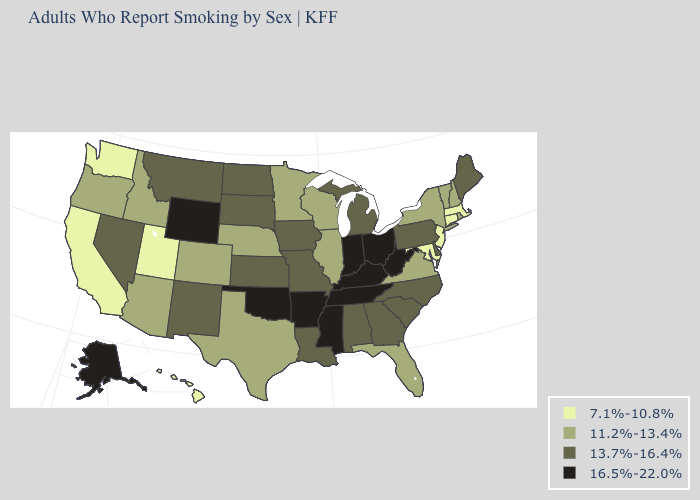What is the lowest value in the MidWest?
Short answer required. 11.2%-13.4%. Name the states that have a value in the range 11.2%-13.4%?
Short answer required. Arizona, Colorado, Florida, Idaho, Illinois, Minnesota, Nebraska, New Hampshire, New York, Oregon, Rhode Island, Texas, Vermont, Virginia, Wisconsin. What is the value of Michigan?
Be succinct. 13.7%-16.4%. What is the lowest value in the USA?
Short answer required. 7.1%-10.8%. Does Idaho have a lower value than West Virginia?
Concise answer only. Yes. Name the states that have a value in the range 7.1%-10.8%?
Keep it brief. California, Connecticut, Hawaii, Maryland, Massachusetts, New Jersey, Utah, Washington. What is the value of Maine?
Give a very brief answer. 13.7%-16.4%. Does Indiana have the lowest value in the MidWest?
Quick response, please. No. What is the value of Vermont?
Quick response, please. 11.2%-13.4%. Name the states that have a value in the range 16.5%-22.0%?
Short answer required. Alaska, Arkansas, Indiana, Kentucky, Mississippi, Ohio, Oklahoma, Tennessee, West Virginia, Wyoming. What is the value of Florida?
Give a very brief answer. 11.2%-13.4%. What is the value of Vermont?
Answer briefly. 11.2%-13.4%. Name the states that have a value in the range 11.2%-13.4%?
Short answer required. Arizona, Colorado, Florida, Idaho, Illinois, Minnesota, Nebraska, New Hampshire, New York, Oregon, Rhode Island, Texas, Vermont, Virginia, Wisconsin. What is the highest value in the West ?
Be succinct. 16.5%-22.0%. Name the states that have a value in the range 11.2%-13.4%?
Short answer required. Arizona, Colorado, Florida, Idaho, Illinois, Minnesota, Nebraska, New Hampshire, New York, Oregon, Rhode Island, Texas, Vermont, Virginia, Wisconsin. 